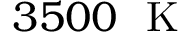Convert formula to latex. <formula><loc_0><loc_0><loc_500><loc_500>3 5 0 0 K</formula> 